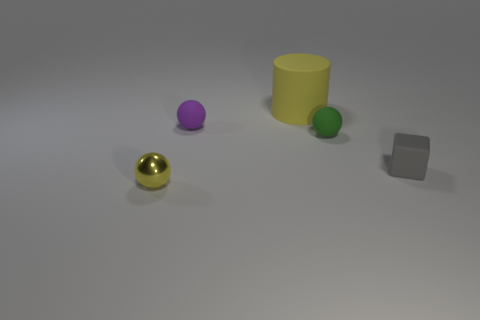Are there any other things that are made of the same material as the small yellow object?
Make the answer very short. No. There is a green ball that is the same size as the purple sphere; what is its material?
Keep it short and to the point. Rubber. How many shiny things are tiny cyan cylinders or large yellow objects?
Provide a succinct answer. 0. There is a small thing that is both in front of the green matte object and to the left of the small gray object; what is its color?
Offer a very short reply. Yellow. What number of cylinders are left of the big cylinder?
Keep it short and to the point. 0. What is the large cylinder made of?
Keep it short and to the point. Rubber. There is a block on the right side of the ball that is behind the tiny matte sphere that is in front of the purple sphere; what is its color?
Offer a terse response. Gray. What number of green objects have the same size as the matte cylinder?
Your answer should be very brief. 0. What color is the tiny thing in front of the tiny gray object?
Offer a terse response. Yellow. What number of other things are the same size as the purple rubber ball?
Your response must be concise. 3. 